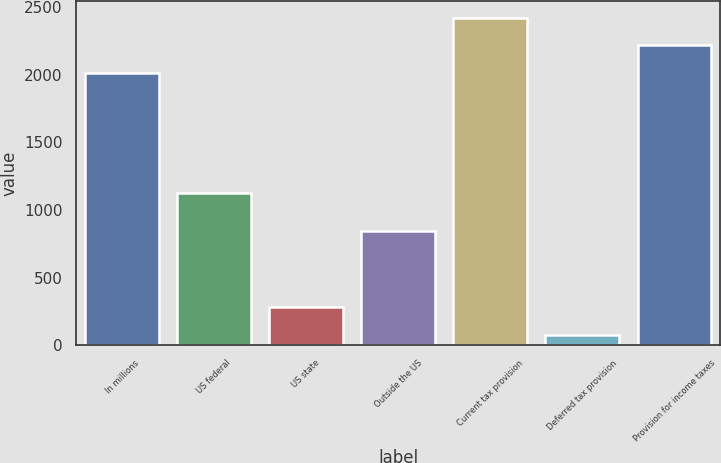Convert chart. <chart><loc_0><loc_0><loc_500><loc_500><bar_chart><fcel>In millions<fcel>US federal<fcel>US state<fcel>Outside the US<fcel>Current tax provision<fcel>Deferred tax provision<fcel>Provision for income taxes<nl><fcel>2010<fcel>1127.1<fcel>281.1<fcel>841.5<fcel>2420.8<fcel>75.7<fcel>2215.4<nl></chart> 